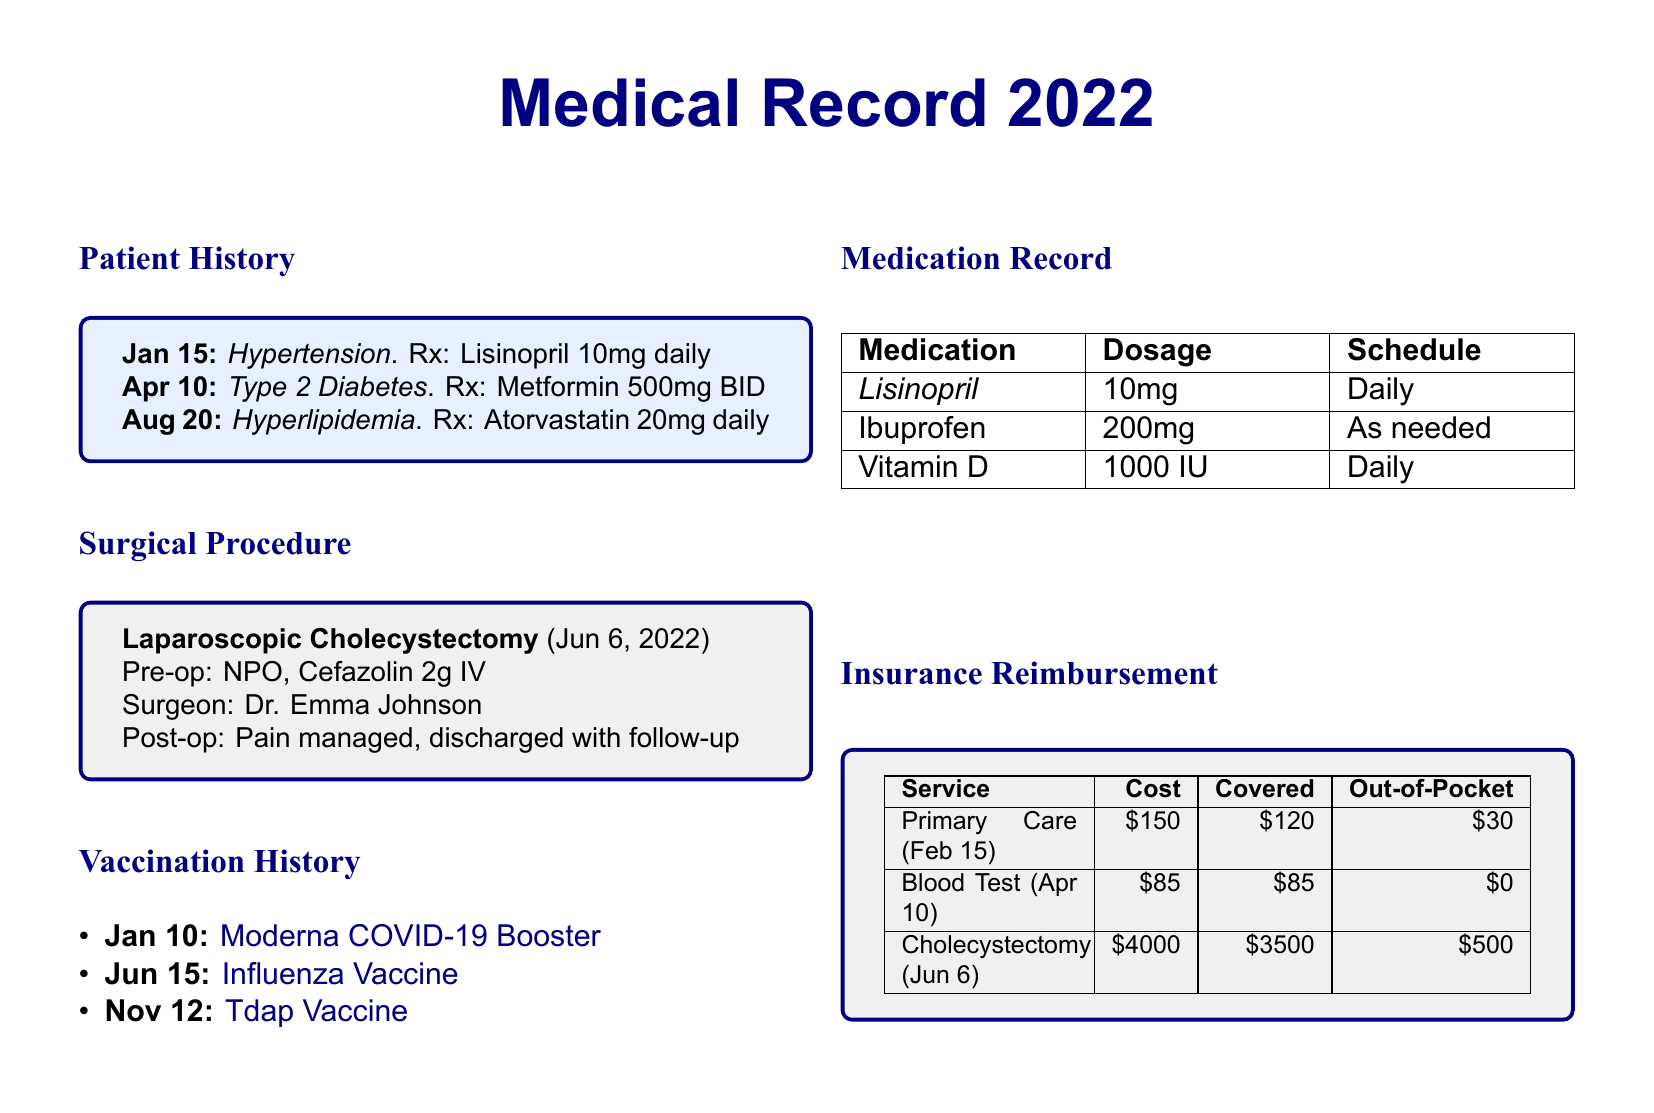What was the diagnosis on January 15? The entry on January 15 indicates the diagnosis of Hypertension.
Answer: Hypertension What medication was prescribed for Type 2 Diabetes? The document states the prescribed medication for Type 2 Diabetes is Metformin.
Answer: Metformin 500mg BID Who performed the laparoscopic cholecystectomy? The surgeon's name listed in the surgical procedure section is Dr. Emma Johnson.
Answer: Dr. Emma Johnson When was the Influenza Vaccine administered? The vaccination history shows that the Influenza Vaccine was administered on June 15.
Answer: Jun 15 What was the cost of the blood test? The cost for the blood test on April 10 is indicated as $85.
Answer: $85 How much did the patient pay out-of-pocket for the cholecystectomy? The document specifies that the out-of-pocket expense for the cholecystectomy was $500.
Answer: $500 Which vaccine is indicated as the first in the vaccination history? The first vaccine listed is the Moderna COVID-19 Booster administered on January 10.
Answer: Moderna COVID-19 Booster What is the dosage for Vitamin D in the medication record? The medication record states the dosage for Vitamin D is 1000 IU.
Answer: 1000 IU What type of medical record is this document? The structure, content, and information provided suggest that this document is a Medical Record for a patient.
Answer: Medical Record 